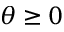<formula> <loc_0><loc_0><loc_500><loc_500>\theta \geq 0</formula> 